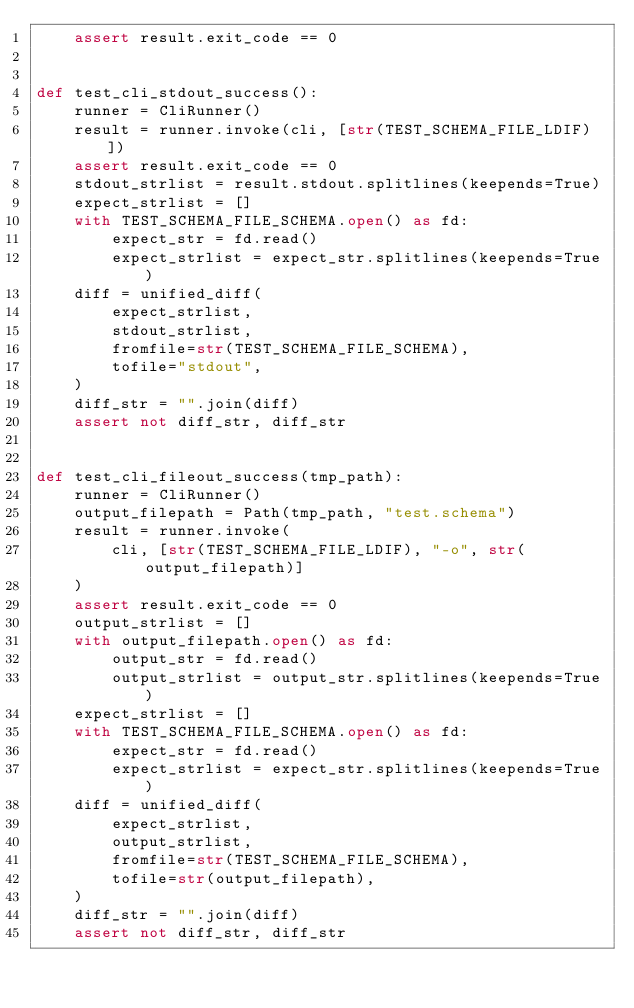Convert code to text. <code><loc_0><loc_0><loc_500><loc_500><_Python_>    assert result.exit_code == 0


def test_cli_stdout_success():
    runner = CliRunner()
    result = runner.invoke(cli, [str(TEST_SCHEMA_FILE_LDIF)])
    assert result.exit_code == 0
    stdout_strlist = result.stdout.splitlines(keepends=True)
    expect_strlist = []
    with TEST_SCHEMA_FILE_SCHEMA.open() as fd:
        expect_str = fd.read()
        expect_strlist = expect_str.splitlines(keepends=True)
    diff = unified_diff(
        expect_strlist,
        stdout_strlist,
        fromfile=str(TEST_SCHEMA_FILE_SCHEMA),
        tofile="stdout",
    )
    diff_str = "".join(diff)
    assert not diff_str, diff_str


def test_cli_fileout_success(tmp_path):
    runner = CliRunner()
    output_filepath = Path(tmp_path, "test.schema")
    result = runner.invoke(
        cli, [str(TEST_SCHEMA_FILE_LDIF), "-o", str(output_filepath)]
    )
    assert result.exit_code == 0
    output_strlist = []
    with output_filepath.open() as fd:
        output_str = fd.read()
        output_strlist = output_str.splitlines(keepends=True)
    expect_strlist = []
    with TEST_SCHEMA_FILE_SCHEMA.open() as fd:
        expect_str = fd.read()
        expect_strlist = expect_str.splitlines(keepends=True)
    diff = unified_diff(
        expect_strlist,
        output_strlist,
        fromfile=str(TEST_SCHEMA_FILE_SCHEMA),
        tofile=str(output_filepath),
    )
    diff_str = "".join(diff)
    assert not diff_str, diff_str
</code> 